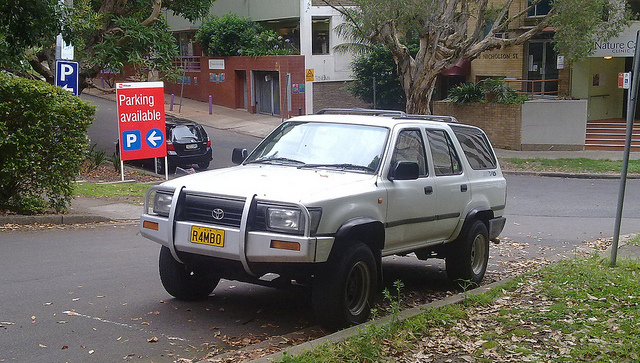Identify the text displayed in this image. Parking p available p R4MBO C Nature 